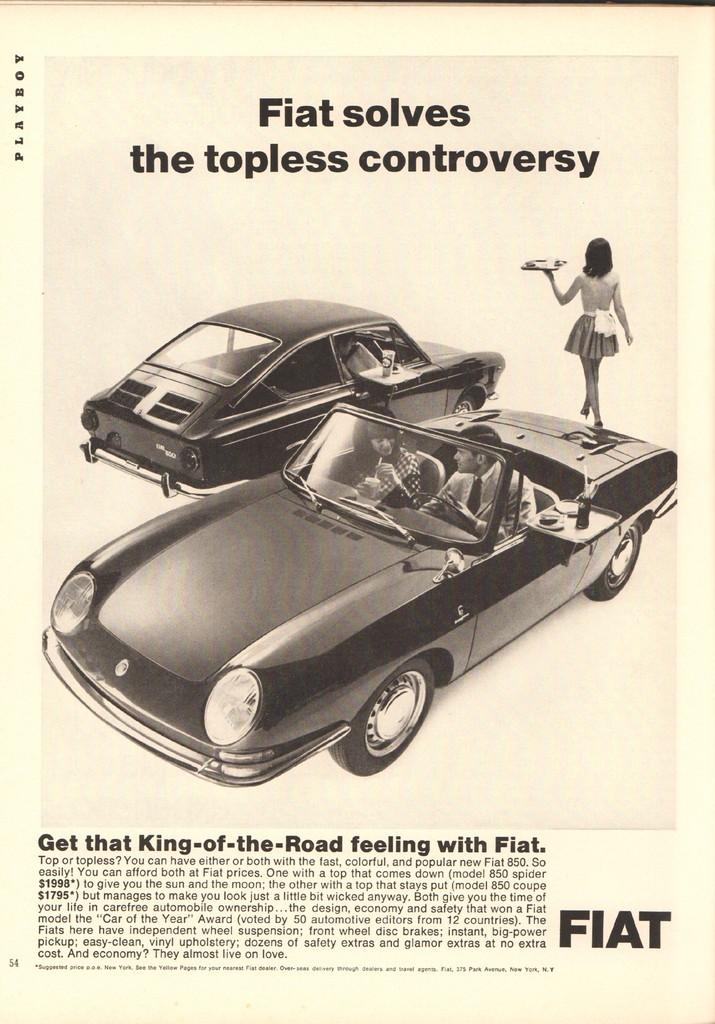What is the main subject of the image? There is an advertisement in the image. What is depicted in the center of the advertisement? There are cars in the center of the advertisement. Who or what can be seen inside the cars? There are people in the cars. What type of information is provided at the top and bottom of the advertisement? There is text at the top and bottom of the advertisement. What type of box is being used to transport the collar in the image? There is no box or collar present in the image; it features an advertisement with cars and people. 